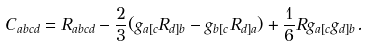<formula> <loc_0><loc_0><loc_500><loc_500>C _ { a b c d } = R _ { a b c d } - \frac { 2 } { 3 } ( g _ { a [ c } R _ { d ] b } - g _ { b [ c } R _ { d ] a } ) + \frac { 1 } { 6 } R g _ { a [ c } g _ { d ] b } .</formula> 